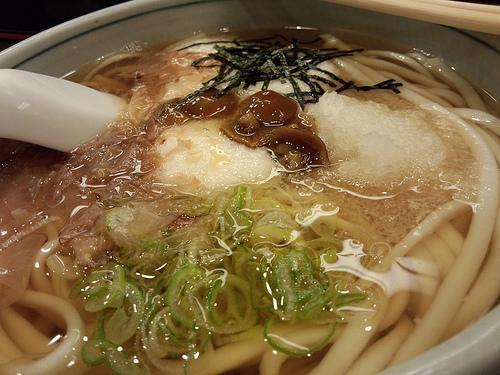How many bowls are there?
Give a very brief answer. 1. 